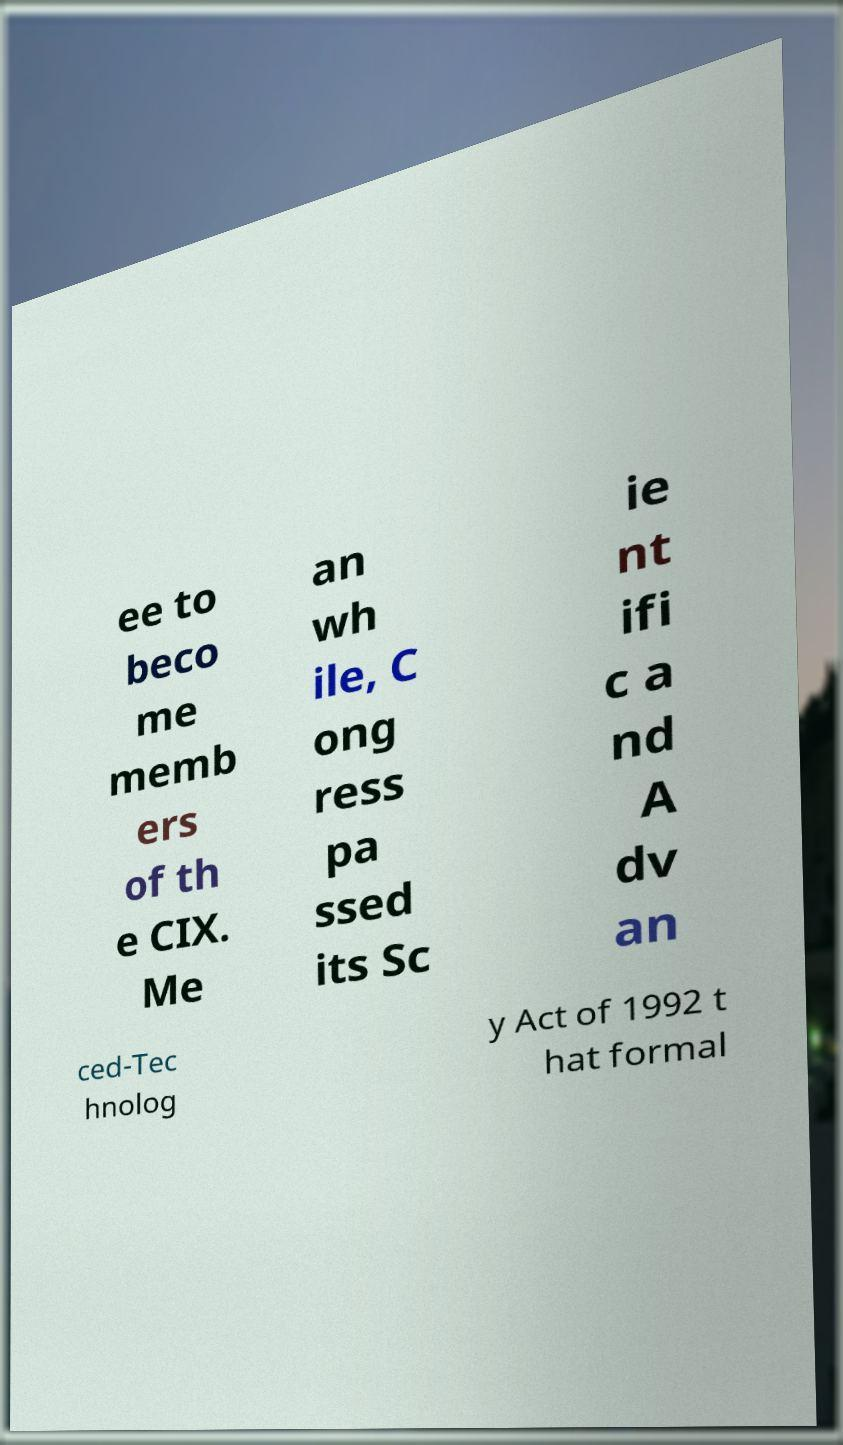Please read and relay the text visible in this image. What does it say? ee to beco me memb ers of th e CIX. Me an wh ile, C ong ress pa ssed its Sc ie nt ifi c a nd A dv an ced-Tec hnolog y Act of 1992 t hat formal 